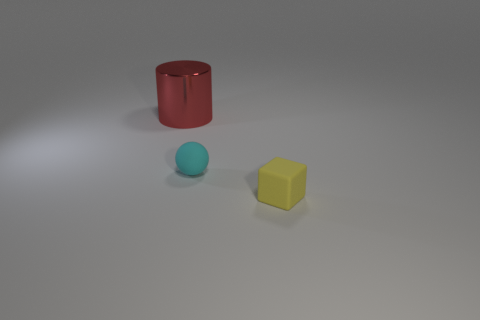Add 2 large metal cylinders. How many objects exist? 5 Subtract all blocks. How many objects are left? 2 Subtract all tiny yellow things. Subtract all tiny cyan spheres. How many objects are left? 1 Add 3 yellow things. How many yellow things are left? 4 Add 2 small brown cubes. How many small brown cubes exist? 2 Subtract 0 yellow balls. How many objects are left? 3 